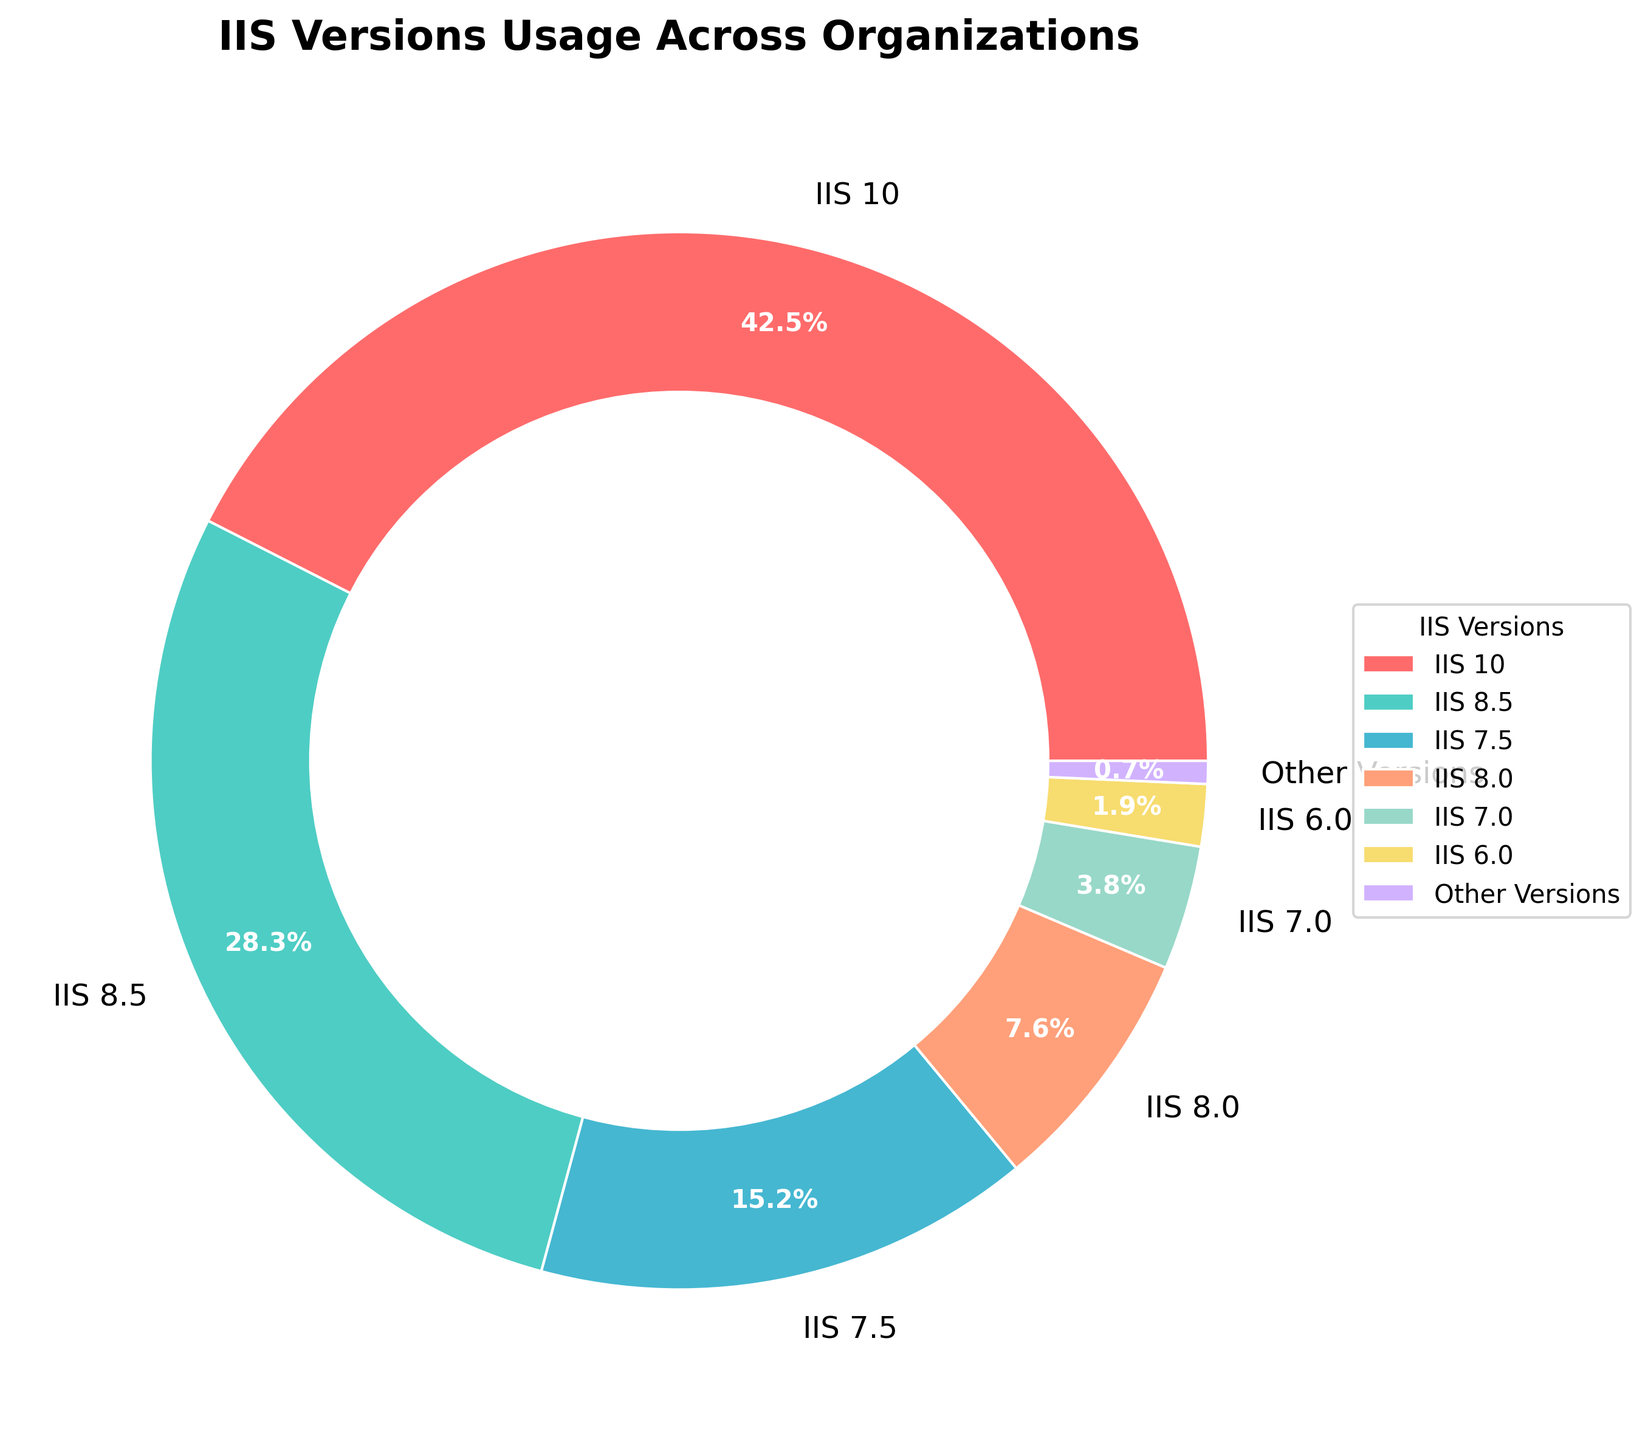What's the most commonly used IIS version according to the pie chart? The largest segment in the pie chart represents the most commonly used IIS version. The segment corresponding to IIS 10 is the largest.
Answer: IIS 10 Which IIS version has the smallest share among those explicitly mentioned? The smallest segment among those explicitly mentioned represents the IIS version with the smallest share. The smallest segment corresponds to IIS 6.0.
Answer: IIS 6.0 What is the combined percentage of IIS 8.5 and IIS 7.5? To find the combined percentage, add the individual percentages of IIS 8.5 and IIS 7.5. IIS 8.5 is 28.3% and IIS 7.5 is 15.2%; adding these gives 28.3 + 15.2 = 43.5%.
Answer: 43.5% Is the percentage of organizations using IIS 10 greater than the combined percentage of those using IIS 7.5 and IIS 8.0? First, find the combined percentage of IIS 7.5 and IIS 8.0 by adding their individual percentages: 15.2% + 7.6% = 22.8%. Then compare this combined percentage to the percentage of IIS 10, which is 42.5%. Since 42.5% > 22.8%, the answer is yes.
Answer: Yes How much larger is the share of IIS 8.5 compared to IIS 7.0? To find how much larger, subtract the percentage of IIS 7.0 from the percentage of IIS 8.5: 28.3% - 3.8% = 24.5%.
Answer: 24.5% What color represents the segment for IIS version 8.0? Look for the segment corresponding to IIS 8.0 in the pie chart and identify its color. The segment for IIS 8.0 is colored light orange.
Answer: Light orange Which version has an identical percentage to the combined share of IIS 8.5 and IIS 7.5? First, find the combined percentage of IIS 8.5 and IIS 7.5: 28.3% + 15.2% = 43.5%. Now, check the percentages of all IIS versions to find an identical match. None of the individual versions match 43.5%.
Answer: None What is the sum of the percentages for IIS 10, IIS 8.5, and IIS 7.5? Add the percentages of IIS 10, IIS 8.5, and IIS 7.5: 42.5% + 28.3% + 15.2% = 86%.
Answer: 86% Does the share of "Other Versions" exceed 1%? Check the segment for "Other Versions" and note its percentage. The segment for "Other Versions" is 0.7%, which does not exceed 1%.
Answer: No Which IIS version has a green segment in the pie chart? Examine the pie chart and identify the segment that is colored green. The segment for IIS 8.5 is colored green.
Answer: IIS 8.5 